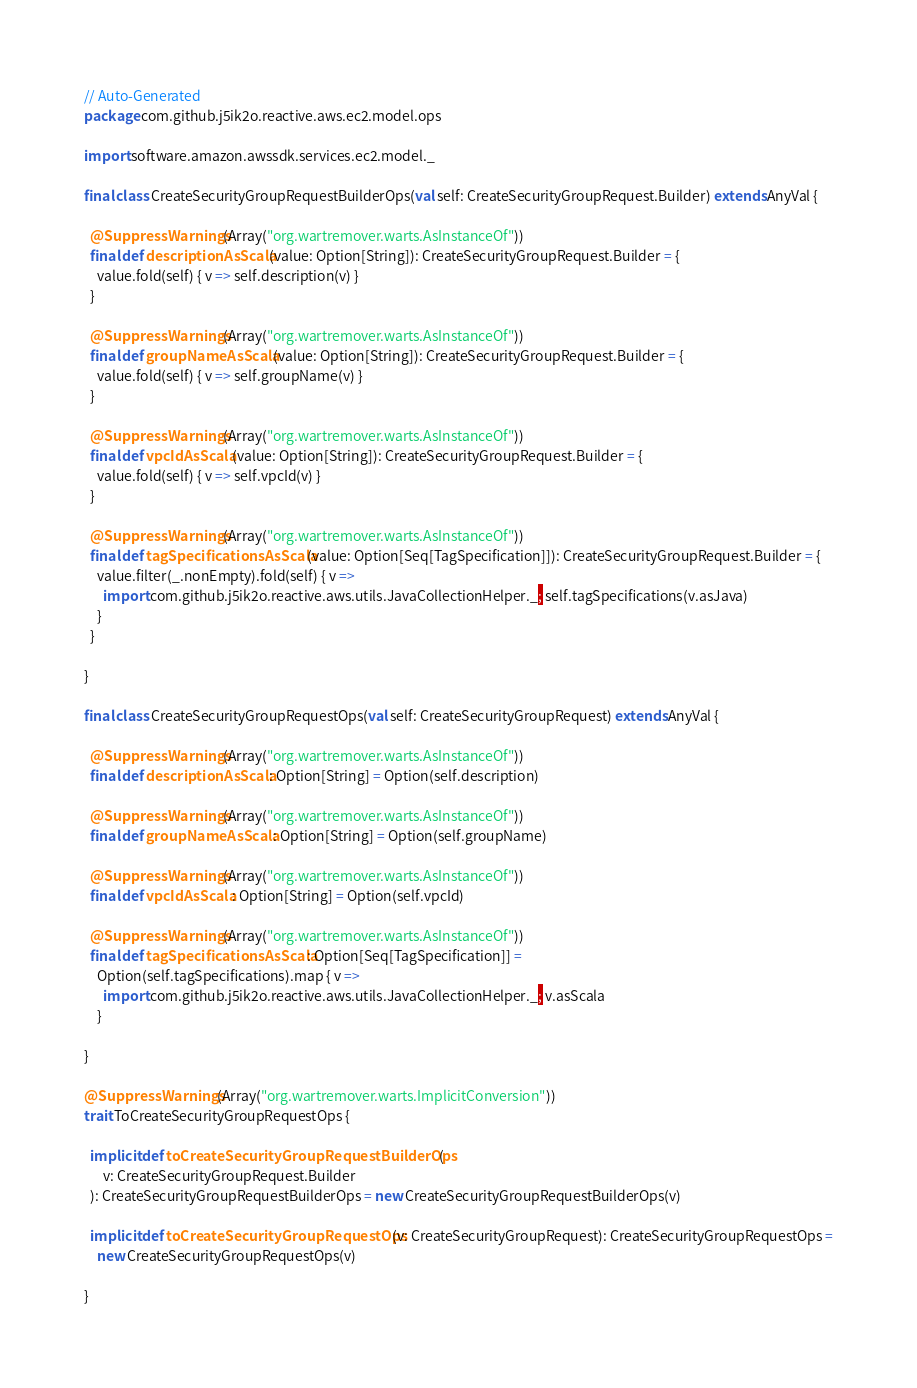<code> <loc_0><loc_0><loc_500><loc_500><_Scala_>// Auto-Generated
package com.github.j5ik2o.reactive.aws.ec2.model.ops

import software.amazon.awssdk.services.ec2.model._

final class CreateSecurityGroupRequestBuilderOps(val self: CreateSecurityGroupRequest.Builder) extends AnyVal {

  @SuppressWarnings(Array("org.wartremover.warts.AsInstanceOf"))
  final def descriptionAsScala(value: Option[String]): CreateSecurityGroupRequest.Builder = {
    value.fold(self) { v => self.description(v) }
  }

  @SuppressWarnings(Array("org.wartremover.warts.AsInstanceOf"))
  final def groupNameAsScala(value: Option[String]): CreateSecurityGroupRequest.Builder = {
    value.fold(self) { v => self.groupName(v) }
  }

  @SuppressWarnings(Array("org.wartremover.warts.AsInstanceOf"))
  final def vpcIdAsScala(value: Option[String]): CreateSecurityGroupRequest.Builder = {
    value.fold(self) { v => self.vpcId(v) }
  }

  @SuppressWarnings(Array("org.wartremover.warts.AsInstanceOf"))
  final def tagSpecificationsAsScala(value: Option[Seq[TagSpecification]]): CreateSecurityGroupRequest.Builder = {
    value.filter(_.nonEmpty).fold(self) { v =>
      import com.github.j5ik2o.reactive.aws.utils.JavaCollectionHelper._; self.tagSpecifications(v.asJava)
    }
  }

}

final class CreateSecurityGroupRequestOps(val self: CreateSecurityGroupRequest) extends AnyVal {

  @SuppressWarnings(Array("org.wartremover.warts.AsInstanceOf"))
  final def descriptionAsScala: Option[String] = Option(self.description)

  @SuppressWarnings(Array("org.wartremover.warts.AsInstanceOf"))
  final def groupNameAsScala: Option[String] = Option(self.groupName)

  @SuppressWarnings(Array("org.wartremover.warts.AsInstanceOf"))
  final def vpcIdAsScala: Option[String] = Option(self.vpcId)

  @SuppressWarnings(Array("org.wartremover.warts.AsInstanceOf"))
  final def tagSpecificationsAsScala: Option[Seq[TagSpecification]] =
    Option(self.tagSpecifications).map { v =>
      import com.github.j5ik2o.reactive.aws.utils.JavaCollectionHelper._; v.asScala
    }

}

@SuppressWarnings(Array("org.wartremover.warts.ImplicitConversion"))
trait ToCreateSecurityGroupRequestOps {

  implicit def toCreateSecurityGroupRequestBuilderOps(
      v: CreateSecurityGroupRequest.Builder
  ): CreateSecurityGroupRequestBuilderOps = new CreateSecurityGroupRequestBuilderOps(v)

  implicit def toCreateSecurityGroupRequestOps(v: CreateSecurityGroupRequest): CreateSecurityGroupRequestOps =
    new CreateSecurityGroupRequestOps(v)

}
</code> 